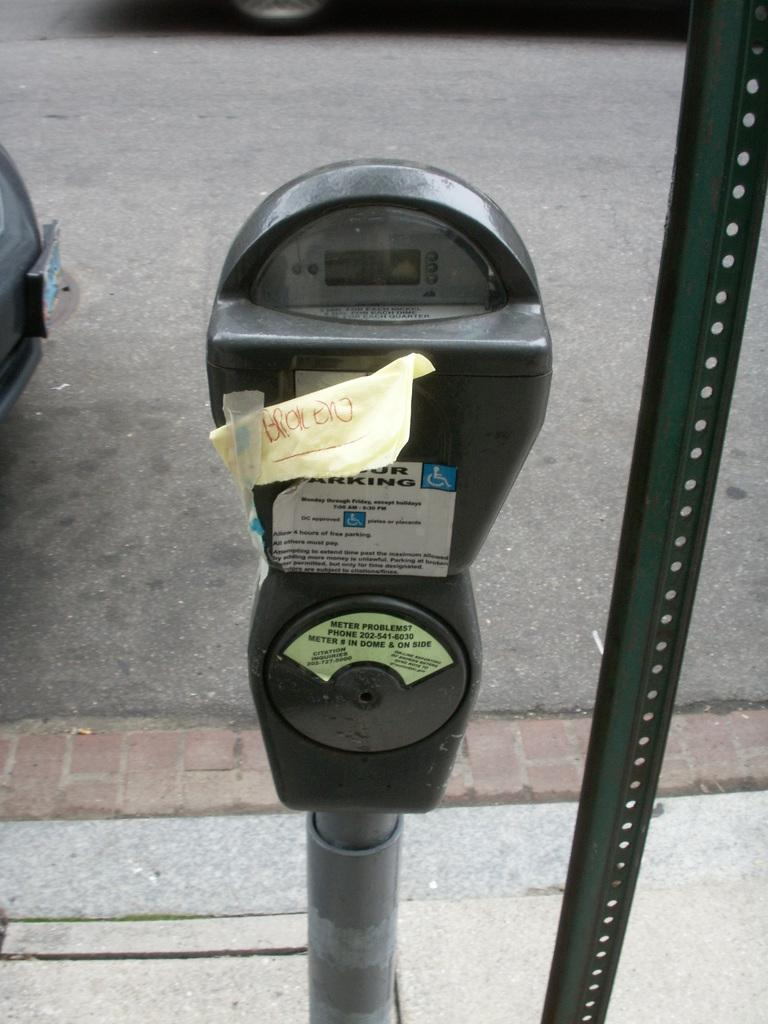<image>
Describe the image concisely. parking meter with a note taped on it stating broken 